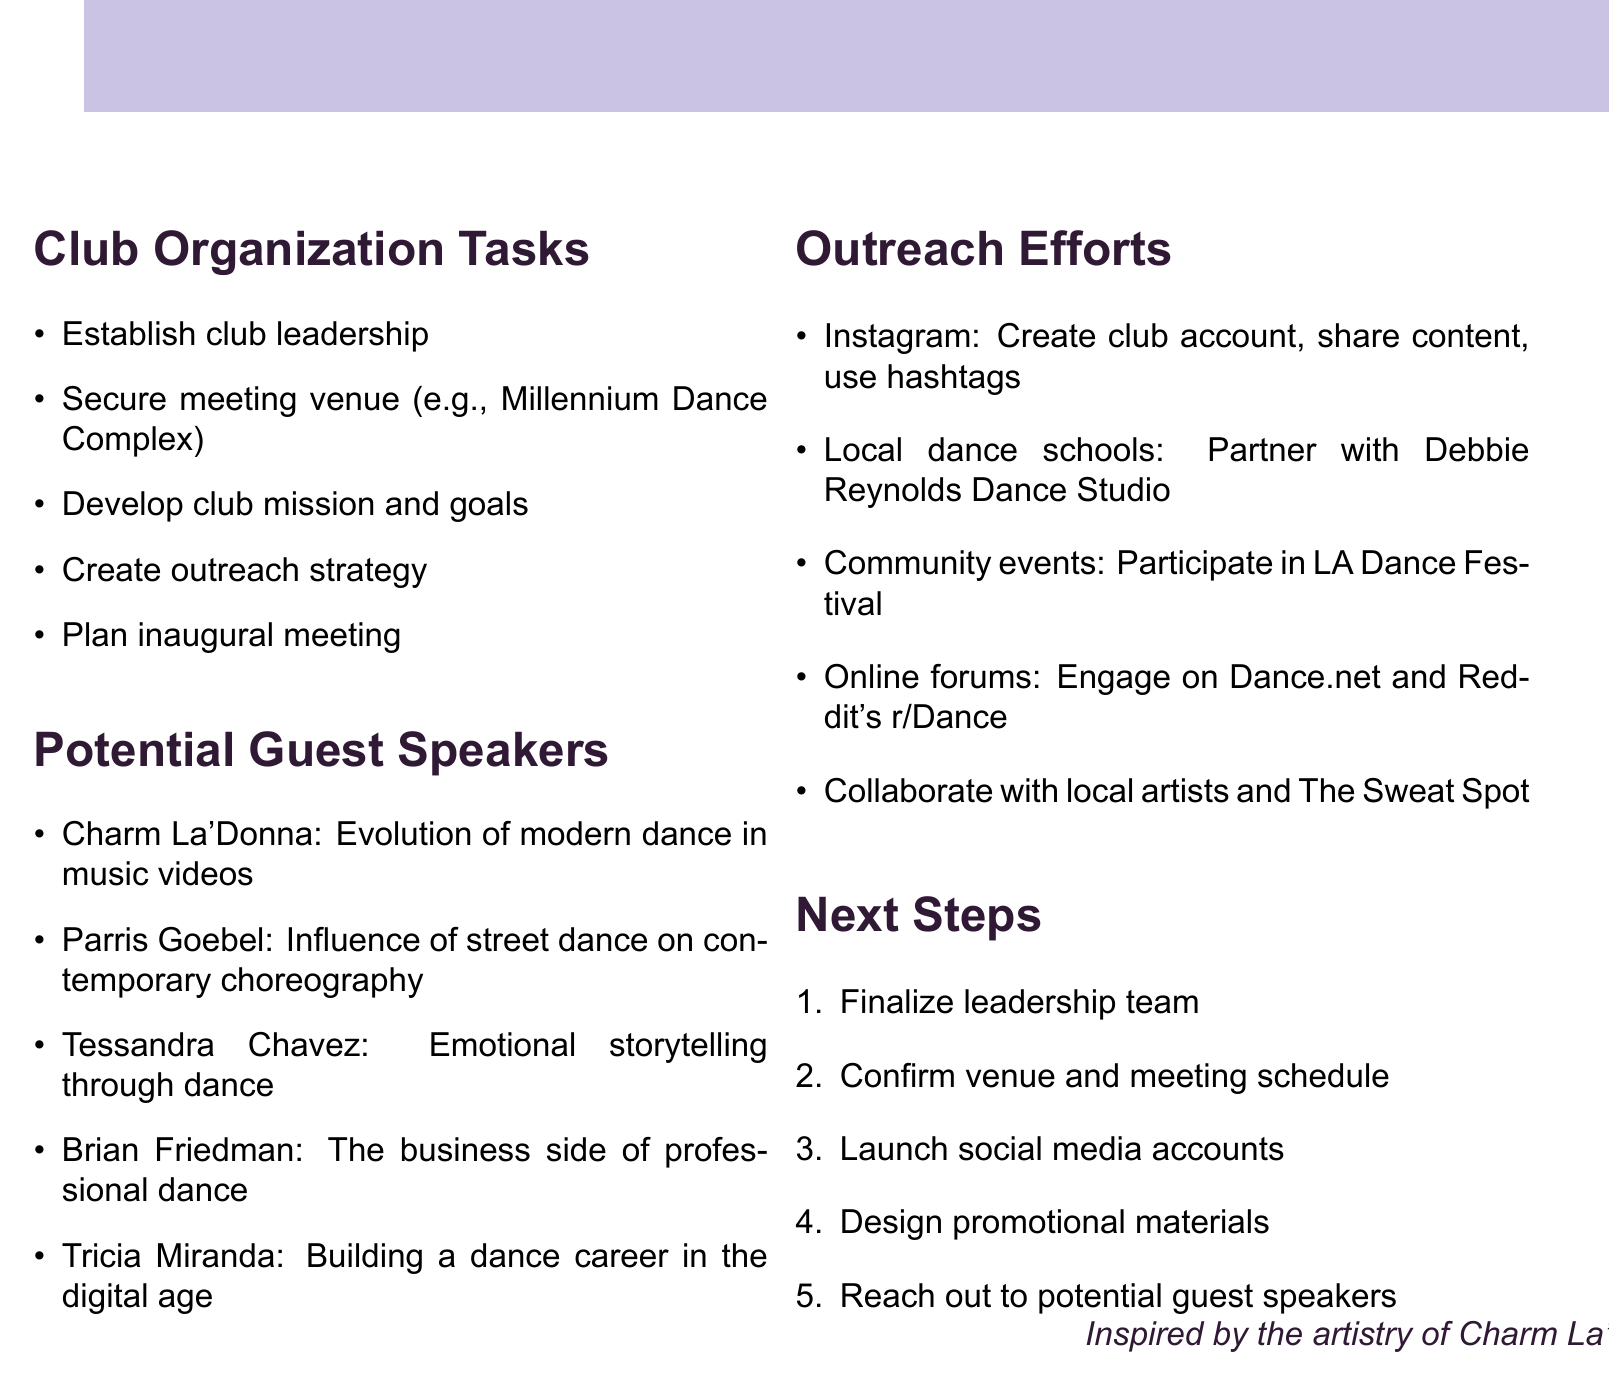What are the roles in club leadership? The document mentions the roles that need to be appointed in the club leadership, which are president, vice president, secretary, and treasurer.
Answer: President, vice president, secretary, treasurer Where is a potential meeting venue? The document lists Millennium Dance Complex as a location for securing a meeting venue.
Answer: Millennium Dance Complex Who is a potential guest speaker known for emotional storytelling through dance? Tessandra Chavez is identified in the document as a guest speaker specializing in emotional storytelling through dance.
Answer: Tessandra Chavez What is the focus of the club's mission? The document states that the club's mission focuses on promoting modern dance and choreography appreciation.
Answer: Promoting modern dance and choreography appreciation Which social media platform is mentioned for outreach? Instagram is listed in the outreach strategy as one of the platforms to promote the club.
Answer: Instagram What event is the club planning to participate in? The document mentions participation in the Los Angeles Dance Festival as part of community outreach efforts.
Answer: Los Angeles Dance Festival How many potential guest speakers are listed in the document? The document provides a total of five potential guest speakers for the club.
Answer: Five What type of activities does the club plan to outline? The document outlines workshops, performances, and discussions as part of the club's plans.
Answer: Workshops, performances, discussions Which local dance school is mentioned for partnership? Debbie Reynolds Dance Studio is identified as a potential partner in outreach efforts in the document.
Answer: Debbie Reynolds Dance Studio 